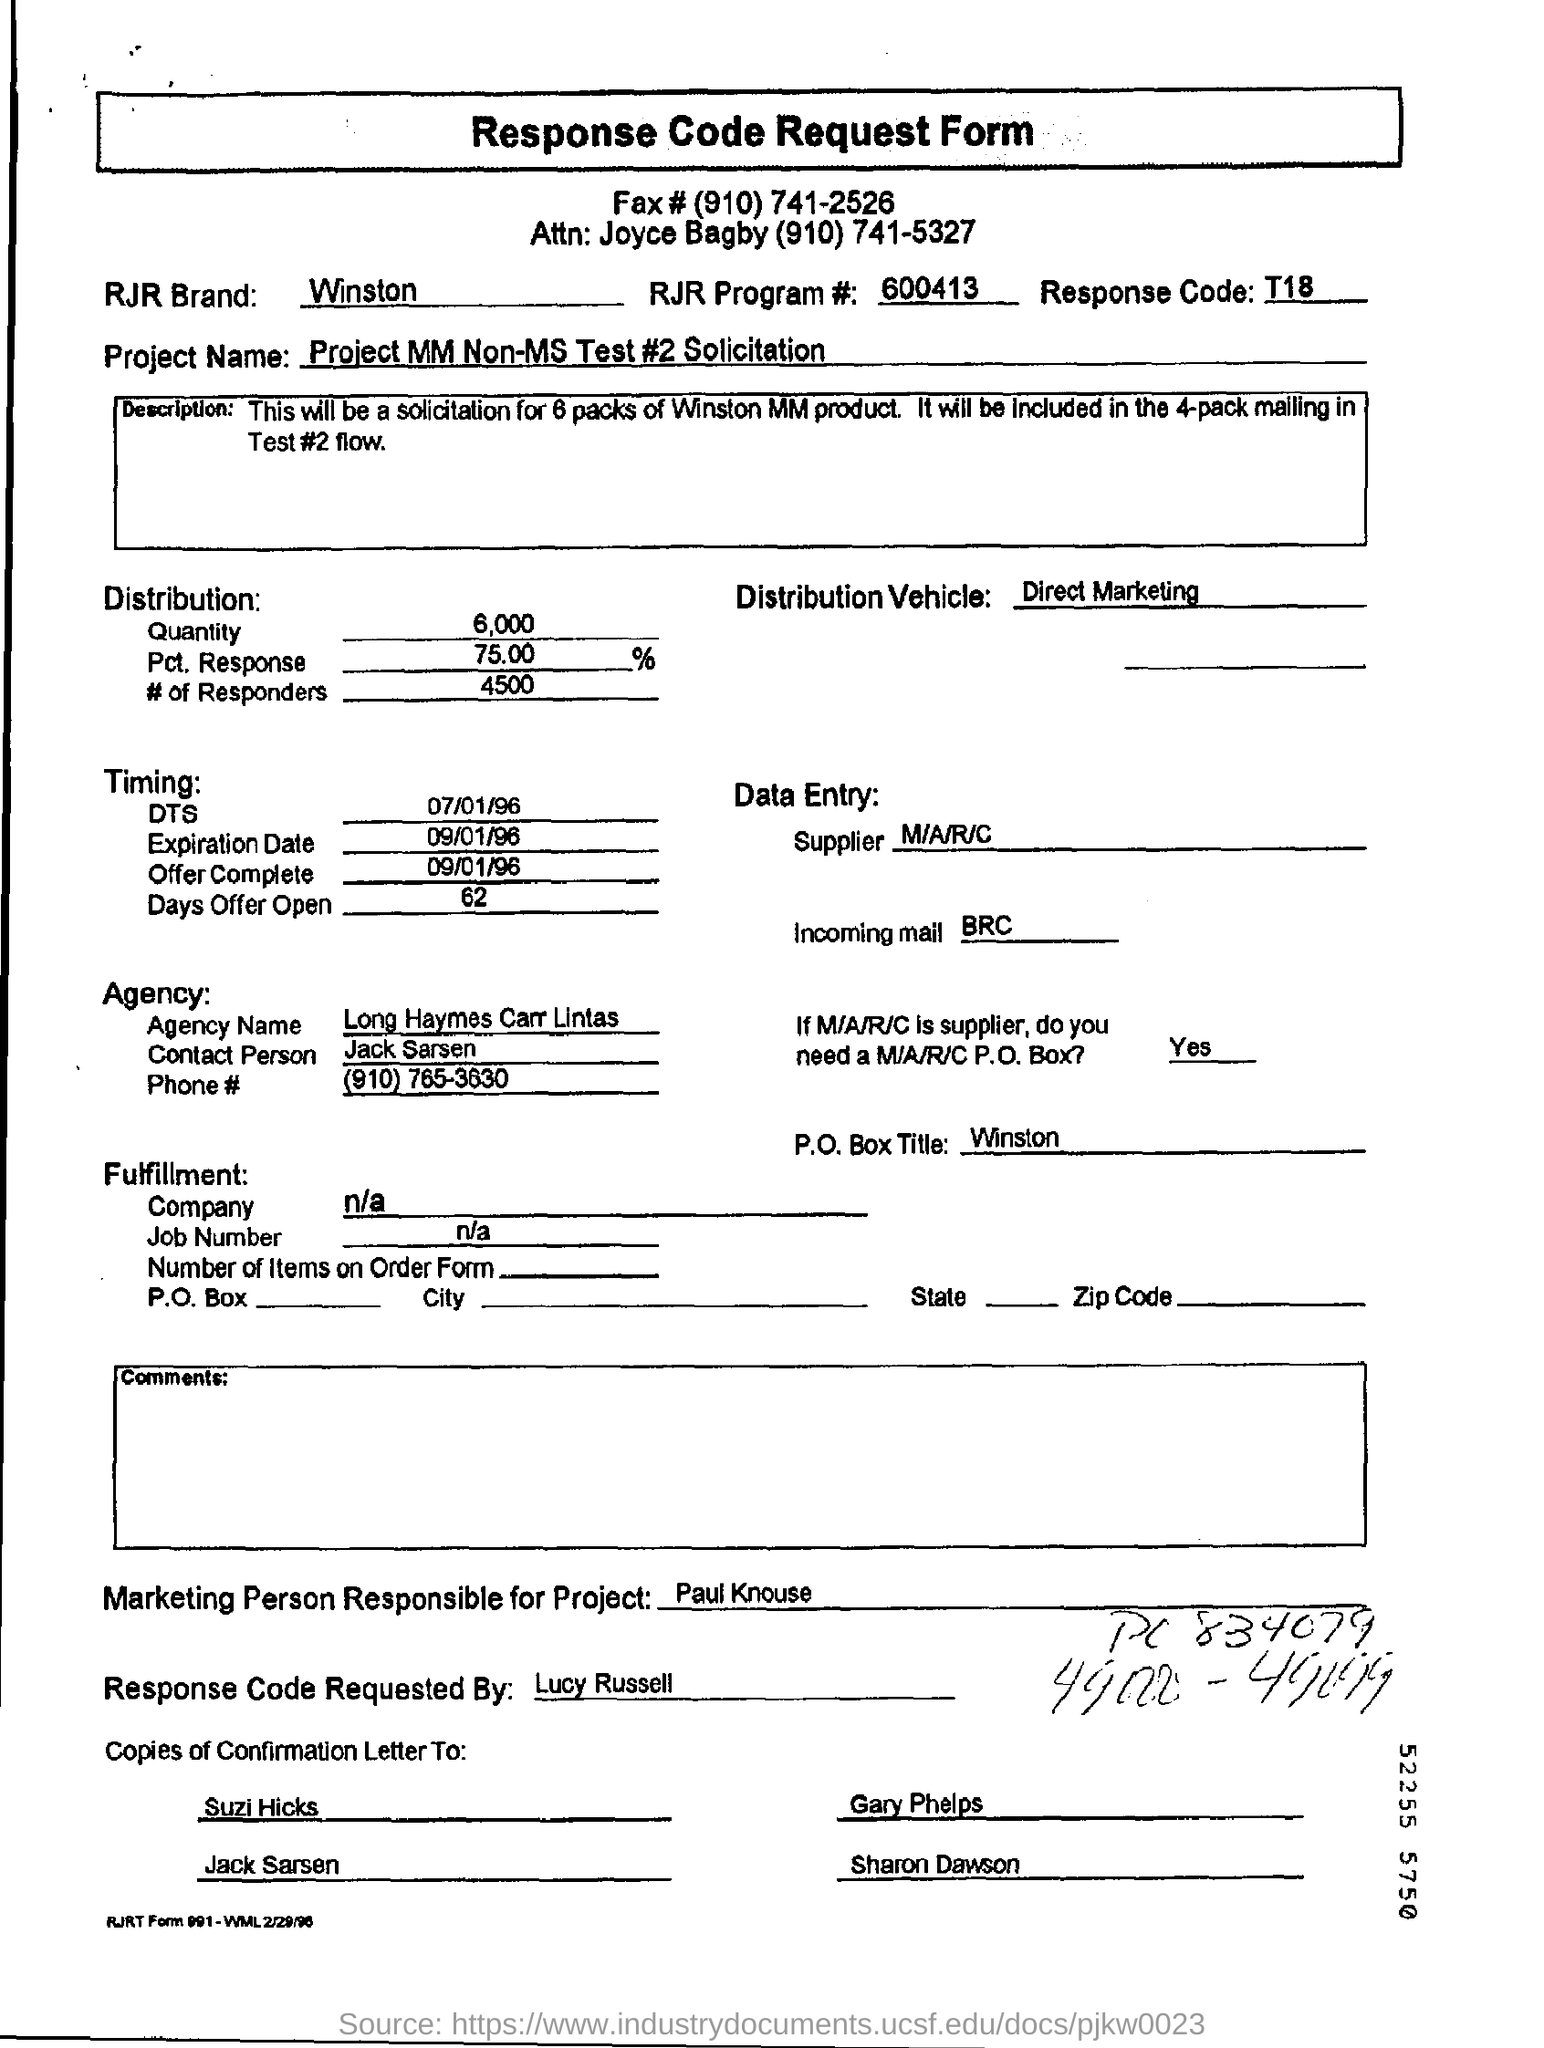Outline some significant characteristics in this image. Winston is the RJR brand. The fax number provided is (910) 741-2526. The response code is T18.. The RJR Program number is 600413, as indicated by the provided text. The project name mentioned in the form is "MM Non-MS Test #2 Solicitation. 